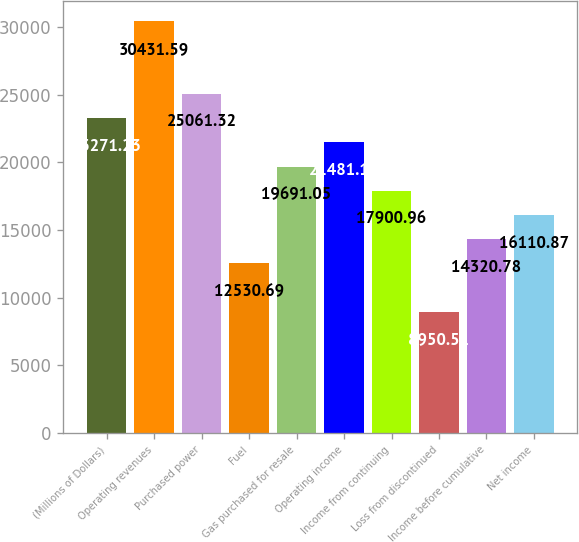<chart> <loc_0><loc_0><loc_500><loc_500><bar_chart><fcel>(Millions of Dollars)<fcel>Operating revenues<fcel>Purchased power<fcel>Fuel<fcel>Gas purchased for resale<fcel>Operating income<fcel>Income from continuing<fcel>Loss from discontinued<fcel>Income before cumulative<fcel>Net income<nl><fcel>23271.2<fcel>30431.6<fcel>25061.3<fcel>12530.7<fcel>19691<fcel>21481.1<fcel>17901<fcel>8950.51<fcel>14320.8<fcel>16110.9<nl></chart> 